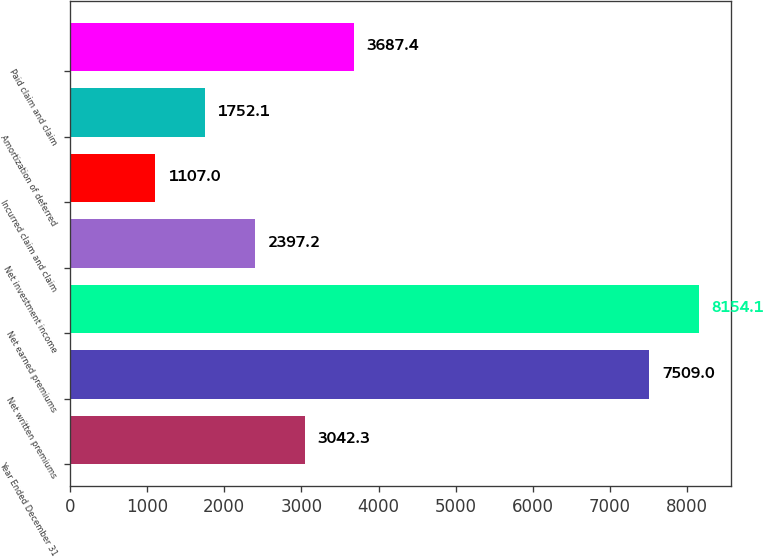Convert chart. <chart><loc_0><loc_0><loc_500><loc_500><bar_chart><fcel>Year Ended December 31<fcel>Net written premiums<fcel>Net earned premiums<fcel>Net investment income<fcel>Incurred claim and claim<fcel>Amortization of deferred<fcel>Paid claim and claim<nl><fcel>3042.3<fcel>7509<fcel>8154.1<fcel>2397.2<fcel>1107<fcel>1752.1<fcel>3687.4<nl></chart> 